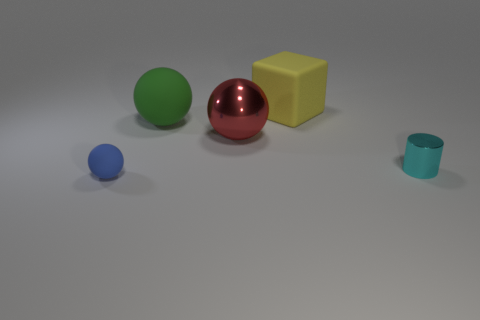Subtract all large spheres. How many spheres are left? 1 Subtract all green spheres. How many spheres are left? 2 Add 5 big matte balls. How many objects exist? 10 Subtract 0 yellow spheres. How many objects are left? 5 Subtract all spheres. How many objects are left? 2 Subtract 1 cubes. How many cubes are left? 0 Subtract all gray cubes. Subtract all blue cylinders. How many cubes are left? 1 Subtract all red cylinders. How many blue cubes are left? 0 Subtract all large red things. Subtract all tiny shiny cylinders. How many objects are left? 3 Add 2 tiny metal cylinders. How many tiny metal cylinders are left? 3 